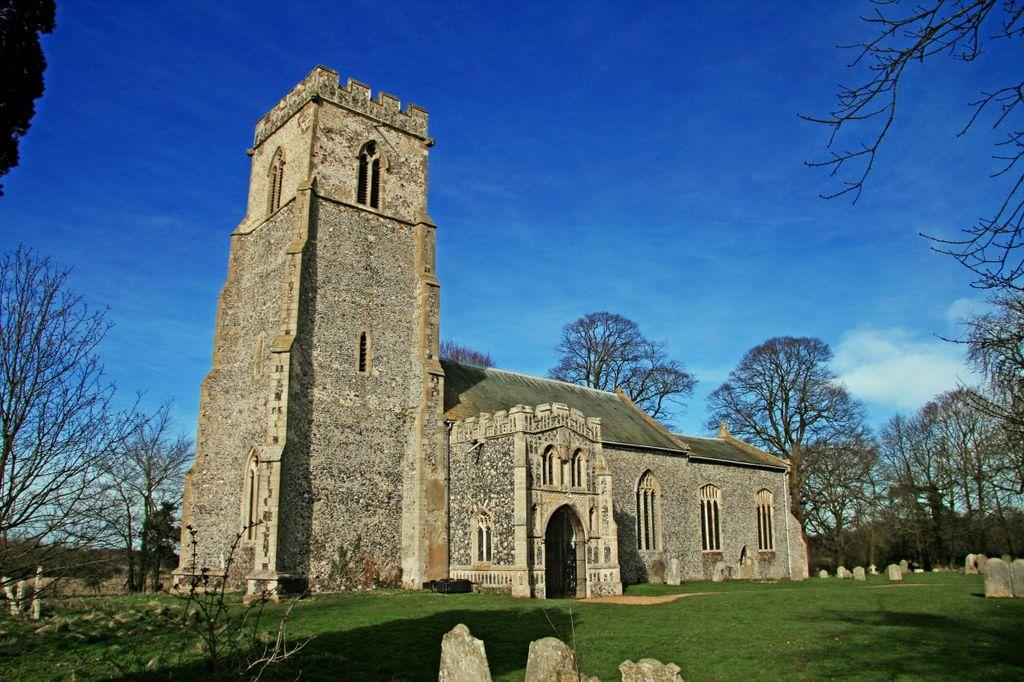What is the main subject in the center of the image? There is a building in the center of the image. What type of vegetation is visible at the bottom of the image? There is grass at the bottom of the image. What can be seen in the background of the image? There are trees in the background of the image. What color is the orange hanging from the tree in the image? There is no orange present in the image; it only features a building, grass, and trees. 